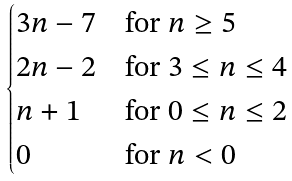Convert formula to latex. <formula><loc_0><loc_0><loc_500><loc_500>\begin{cases} 3 n - 7 & \text {for $n\geq 5$} \\ 2 n - 2 & \text {for $3\leq n\leq 4$} \\ n + 1 & \text {for $0\leq n\leq 2$} \\ 0 & \text {for $n<0$} \\ \end{cases}</formula> 